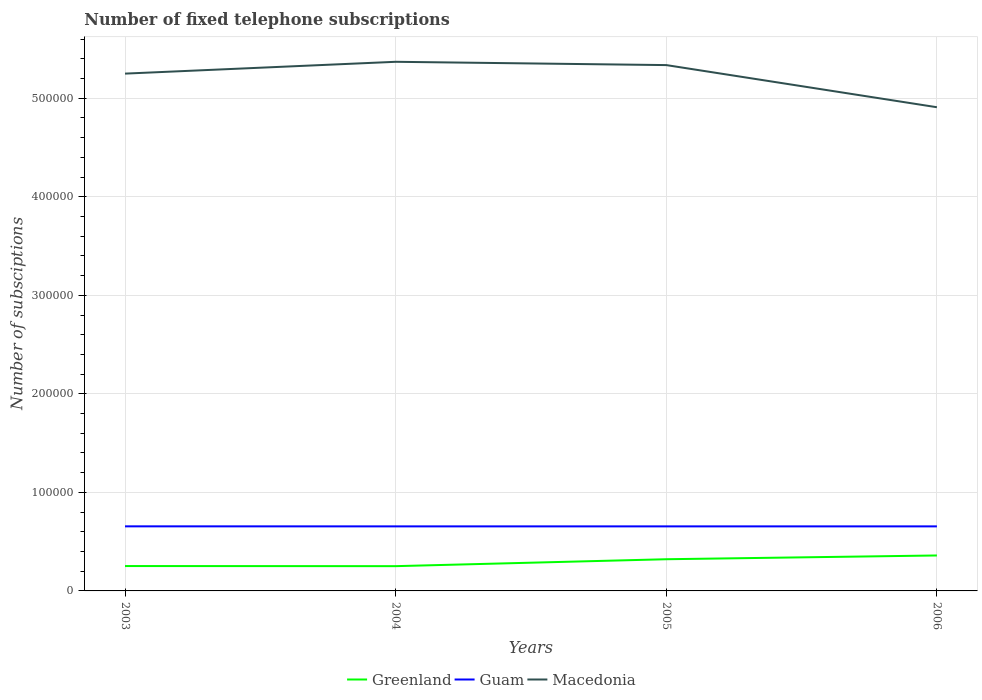Does the line corresponding to Greenland intersect with the line corresponding to Guam?
Your answer should be very brief. No. Across all years, what is the maximum number of fixed telephone subscriptions in Greenland?
Your answer should be very brief. 2.51e+04. In which year was the number of fixed telephone subscriptions in Macedonia maximum?
Keep it short and to the point. 2006. What is the total number of fixed telephone subscriptions in Guam in the graph?
Provide a short and direct response. 31. What is the difference between the highest and the second highest number of fixed telephone subscriptions in Macedonia?
Provide a short and direct response. 4.61e+04. How many years are there in the graph?
Ensure brevity in your answer.  4. What is the difference between two consecutive major ticks on the Y-axis?
Offer a very short reply. 1.00e+05. Does the graph contain grids?
Your response must be concise. Yes. What is the title of the graph?
Provide a short and direct response. Number of fixed telephone subscriptions. What is the label or title of the Y-axis?
Your answer should be very brief. Number of subsciptions. What is the Number of subsciptions of Greenland in 2003?
Give a very brief answer. 2.52e+04. What is the Number of subsciptions of Guam in 2003?
Give a very brief answer. 6.55e+04. What is the Number of subsciptions in Macedonia in 2003?
Ensure brevity in your answer.  5.25e+05. What is the Number of subsciptions of Greenland in 2004?
Keep it short and to the point. 2.51e+04. What is the Number of subsciptions of Guam in 2004?
Provide a short and direct response. 6.55e+04. What is the Number of subsciptions in Macedonia in 2004?
Make the answer very short. 5.37e+05. What is the Number of subsciptions in Greenland in 2005?
Keep it short and to the point. 3.22e+04. What is the Number of subsciptions in Guam in 2005?
Provide a succinct answer. 6.55e+04. What is the Number of subsciptions in Macedonia in 2005?
Ensure brevity in your answer.  5.34e+05. What is the Number of subsciptions of Greenland in 2006?
Your response must be concise. 3.60e+04. What is the Number of subsciptions of Guam in 2006?
Offer a very short reply. 6.55e+04. What is the Number of subsciptions of Macedonia in 2006?
Keep it short and to the point. 4.91e+05. Across all years, what is the maximum Number of subsciptions of Greenland?
Your answer should be very brief. 3.60e+04. Across all years, what is the maximum Number of subsciptions in Guam?
Offer a very short reply. 6.55e+04. Across all years, what is the maximum Number of subsciptions of Macedonia?
Ensure brevity in your answer.  5.37e+05. Across all years, what is the minimum Number of subsciptions in Greenland?
Offer a very short reply. 2.51e+04. Across all years, what is the minimum Number of subsciptions in Guam?
Make the answer very short. 6.55e+04. Across all years, what is the minimum Number of subsciptions of Macedonia?
Make the answer very short. 4.91e+05. What is the total Number of subsciptions of Greenland in the graph?
Your answer should be compact. 1.19e+05. What is the total Number of subsciptions in Guam in the graph?
Your answer should be compact. 2.62e+05. What is the total Number of subsciptions of Macedonia in the graph?
Keep it short and to the point. 2.09e+06. What is the difference between the Number of subsciptions of Greenland in 2003 and that in 2004?
Give a very brief answer. 120. What is the difference between the Number of subsciptions in Guam in 2003 and that in 2004?
Give a very brief answer. 31. What is the difference between the Number of subsciptions of Macedonia in 2003 and that in 2004?
Offer a terse response. -1.20e+04. What is the difference between the Number of subsciptions of Greenland in 2003 and that in 2005?
Keep it short and to the point. -6903. What is the difference between the Number of subsciptions in Macedonia in 2003 and that in 2005?
Your answer should be very brief. -8656. What is the difference between the Number of subsciptions of Greenland in 2003 and that in 2006?
Offer a very short reply. -1.07e+04. What is the difference between the Number of subsciptions of Guam in 2003 and that in 2006?
Offer a terse response. 31. What is the difference between the Number of subsciptions in Macedonia in 2003 and that in 2006?
Your answer should be very brief. 3.41e+04. What is the difference between the Number of subsciptions in Greenland in 2004 and that in 2005?
Ensure brevity in your answer.  -7023. What is the difference between the Number of subsciptions in Macedonia in 2004 and that in 2005?
Offer a terse response. 3344. What is the difference between the Number of subsciptions of Greenland in 2004 and that in 2006?
Your response must be concise. -1.09e+04. What is the difference between the Number of subsciptions of Guam in 2004 and that in 2006?
Offer a very short reply. 0. What is the difference between the Number of subsciptions of Macedonia in 2004 and that in 2006?
Give a very brief answer. 4.61e+04. What is the difference between the Number of subsciptions of Greenland in 2005 and that in 2006?
Offer a terse response. -3832. What is the difference between the Number of subsciptions of Guam in 2005 and that in 2006?
Offer a very short reply. 0. What is the difference between the Number of subsciptions of Macedonia in 2005 and that in 2006?
Offer a very short reply. 4.28e+04. What is the difference between the Number of subsciptions of Greenland in 2003 and the Number of subsciptions of Guam in 2004?
Your answer should be very brief. -4.03e+04. What is the difference between the Number of subsciptions in Greenland in 2003 and the Number of subsciptions in Macedonia in 2004?
Provide a succinct answer. -5.12e+05. What is the difference between the Number of subsciptions in Guam in 2003 and the Number of subsciptions in Macedonia in 2004?
Keep it short and to the point. -4.71e+05. What is the difference between the Number of subsciptions in Greenland in 2003 and the Number of subsciptions in Guam in 2005?
Provide a succinct answer. -4.03e+04. What is the difference between the Number of subsciptions of Greenland in 2003 and the Number of subsciptions of Macedonia in 2005?
Offer a terse response. -5.08e+05. What is the difference between the Number of subsciptions of Guam in 2003 and the Number of subsciptions of Macedonia in 2005?
Your response must be concise. -4.68e+05. What is the difference between the Number of subsciptions in Greenland in 2003 and the Number of subsciptions in Guam in 2006?
Provide a short and direct response. -4.03e+04. What is the difference between the Number of subsciptions of Greenland in 2003 and the Number of subsciptions of Macedonia in 2006?
Provide a succinct answer. -4.66e+05. What is the difference between the Number of subsciptions in Guam in 2003 and the Number of subsciptions in Macedonia in 2006?
Your response must be concise. -4.25e+05. What is the difference between the Number of subsciptions in Greenland in 2004 and the Number of subsciptions in Guam in 2005?
Your answer should be very brief. -4.04e+04. What is the difference between the Number of subsciptions in Greenland in 2004 and the Number of subsciptions in Macedonia in 2005?
Your response must be concise. -5.09e+05. What is the difference between the Number of subsciptions of Guam in 2004 and the Number of subsciptions of Macedonia in 2005?
Ensure brevity in your answer.  -4.68e+05. What is the difference between the Number of subsciptions in Greenland in 2004 and the Number of subsciptions in Guam in 2006?
Make the answer very short. -4.04e+04. What is the difference between the Number of subsciptions of Greenland in 2004 and the Number of subsciptions of Macedonia in 2006?
Your response must be concise. -4.66e+05. What is the difference between the Number of subsciptions in Guam in 2004 and the Number of subsciptions in Macedonia in 2006?
Provide a succinct answer. -4.25e+05. What is the difference between the Number of subsciptions of Greenland in 2005 and the Number of subsciptions of Guam in 2006?
Your response must be concise. -3.33e+04. What is the difference between the Number of subsciptions in Greenland in 2005 and the Number of subsciptions in Macedonia in 2006?
Your response must be concise. -4.59e+05. What is the difference between the Number of subsciptions in Guam in 2005 and the Number of subsciptions in Macedonia in 2006?
Provide a short and direct response. -4.25e+05. What is the average Number of subsciptions of Greenland per year?
Provide a short and direct response. 2.96e+04. What is the average Number of subsciptions of Guam per year?
Your answer should be compact. 6.55e+04. What is the average Number of subsciptions of Macedonia per year?
Give a very brief answer. 5.22e+05. In the year 2003, what is the difference between the Number of subsciptions of Greenland and Number of subsciptions of Guam?
Your answer should be compact. -4.03e+04. In the year 2003, what is the difference between the Number of subsciptions in Greenland and Number of subsciptions in Macedonia?
Give a very brief answer. -5.00e+05. In the year 2003, what is the difference between the Number of subsciptions of Guam and Number of subsciptions of Macedonia?
Provide a succinct answer. -4.59e+05. In the year 2004, what is the difference between the Number of subsciptions in Greenland and Number of subsciptions in Guam?
Ensure brevity in your answer.  -4.04e+04. In the year 2004, what is the difference between the Number of subsciptions in Greenland and Number of subsciptions in Macedonia?
Keep it short and to the point. -5.12e+05. In the year 2004, what is the difference between the Number of subsciptions in Guam and Number of subsciptions in Macedonia?
Offer a terse response. -4.72e+05. In the year 2005, what is the difference between the Number of subsciptions in Greenland and Number of subsciptions in Guam?
Your response must be concise. -3.33e+04. In the year 2005, what is the difference between the Number of subsciptions of Greenland and Number of subsciptions of Macedonia?
Ensure brevity in your answer.  -5.02e+05. In the year 2005, what is the difference between the Number of subsciptions of Guam and Number of subsciptions of Macedonia?
Provide a short and direct response. -4.68e+05. In the year 2006, what is the difference between the Number of subsciptions in Greenland and Number of subsciptions in Guam?
Make the answer very short. -2.95e+04. In the year 2006, what is the difference between the Number of subsciptions of Greenland and Number of subsciptions of Macedonia?
Your response must be concise. -4.55e+05. In the year 2006, what is the difference between the Number of subsciptions in Guam and Number of subsciptions in Macedonia?
Provide a short and direct response. -4.25e+05. What is the ratio of the Number of subsciptions in Greenland in 2003 to that in 2004?
Keep it short and to the point. 1. What is the ratio of the Number of subsciptions in Macedonia in 2003 to that in 2004?
Offer a terse response. 0.98. What is the ratio of the Number of subsciptions in Greenland in 2003 to that in 2005?
Offer a terse response. 0.79. What is the ratio of the Number of subsciptions of Guam in 2003 to that in 2005?
Give a very brief answer. 1. What is the ratio of the Number of subsciptions of Macedonia in 2003 to that in 2005?
Ensure brevity in your answer.  0.98. What is the ratio of the Number of subsciptions in Greenland in 2003 to that in 2006?
Give a very brief answer. 0.7. What is the ratio of the Number of subsciptions in Macedonia in 2003 to that in 2006?
Your answer should be compact. 1.07. What is the ratio of the Number of subsciptions in Greenland in 2004 to that in 2005?
Provide a succinct answer. 0.78. What is the ratio of the Number of subsciptions of Guam in 2004 to that in 2005?
Your response must be concise. 1. What is the ratio of the Number of subsciptions of Greenland in 2004 to that in 2006?
Keep it short and to the point. 0.7. What is the ratio of the Number of subsciptions in Guam in 2004 to that in 2006?
Your answer should be compact. 1. What is the ratio of the Number of subsciptions of Macedonia in 2004 to that in 2006?
Make the answer very short. 1.09. What is the ratio of the Number of subsciptions in Greenland in 2005 to that in 2006?
Offer a very short reply. 0.89. What is the ratio of the Number of subsciptions of Macedonia in 2005 to that in 2006?
Make the answer very short. 1.09. What is the difference between the highest and the second highest Number of subsciptions in Greenland?
Provide a short and direct response. 3832. What is the difference between the highest and the second highest Number of subsciptions of Macedonia?
Offer a terse response. 3344. What is the difference between the highest and the lowest Number of subsciptions of Greenland?
Offer a terse response. 1.09e+04. What is the difference between the highest and the lowest Number of subsciptions in Guam?
Keep it short and to the point. 31. What is the difference between the highest and the lowest Number of subsciptions of Macedonia?
Keep it short and to the point. 4.61e+04. 